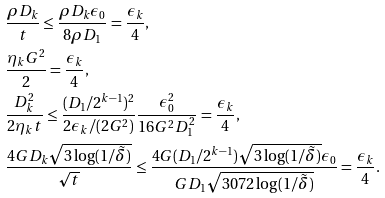Convert formula to latex. <formula><loc_0><loc_0><loc_500><loc_500>& \frac { \rho D _ { k } } { t } \leq \frac { \rho D _ { k } \epsilon _ { 0 } } { 8 \rho D _ { 1 } } = \frac { \epsilon _ { k } } { 4 } , \\ & \frac { \eta _ { k } G ^ { 2 } } { 2 } = \frac { \epsilon _ { k } } { 4 } , \\ & \frac { D _ { k } ^ { 2 } } { 2 \eta _ { k } t } \leq \frac { ( D _ { 1 } / 2 ^ { k - 1 } ) ^ { 2 } } { 2 \epsilon _ { k } / ( 2 G ^ { 2 } ) } \frac { \epsilon _ { 0 } ^ { 2 } } { 1 6 G ^ { 2 } D _ { 1 } ^ { 2 } } = \frac { \epsilon _ { k } } { 4 } , \\ & \frac { 4 G D _ { k } \sqrt { 3 \log ( 1 / \tilde { \delta } ) } } { \sqrt { t } } \leq \frac { 4 G ( D _ { 1 } / 2 ^ { k - 1 } ) \sqrt { 3 \log ( 1 / \tilde { \delta } ) } \epsilon _ { 0 } } { G D _ { 1 } \sqrt { 3 0 7 2 \log ( 1 / \tilde { \delta } ) } } = \frac { \epsilon _ { k } } { 4 } .</formula> 